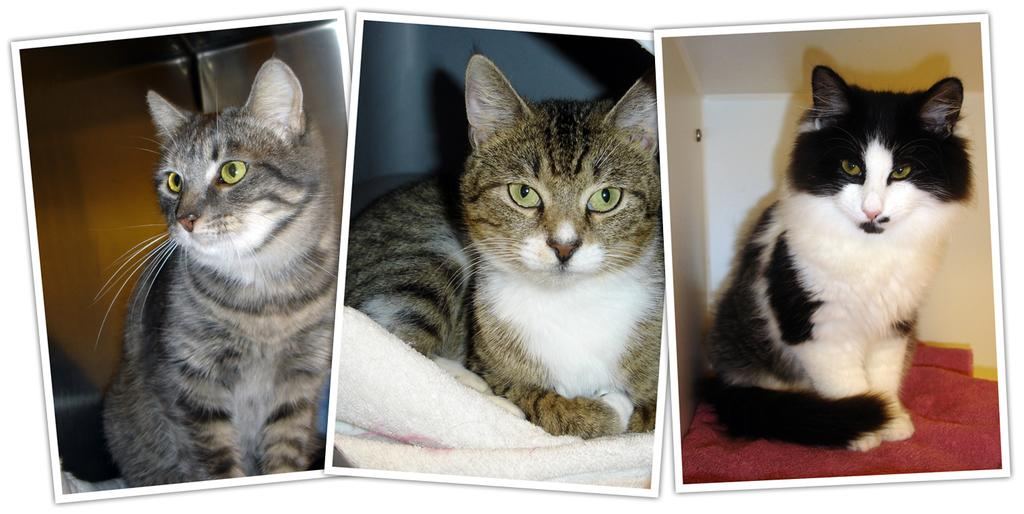What type of image is being described? The image is a collage that has been edited. How many cats are present in the image? There are three cats in the image. What are the cats resting on? The cats are on napkins. What type of page is the collage? There is no mention of a page in the image. 